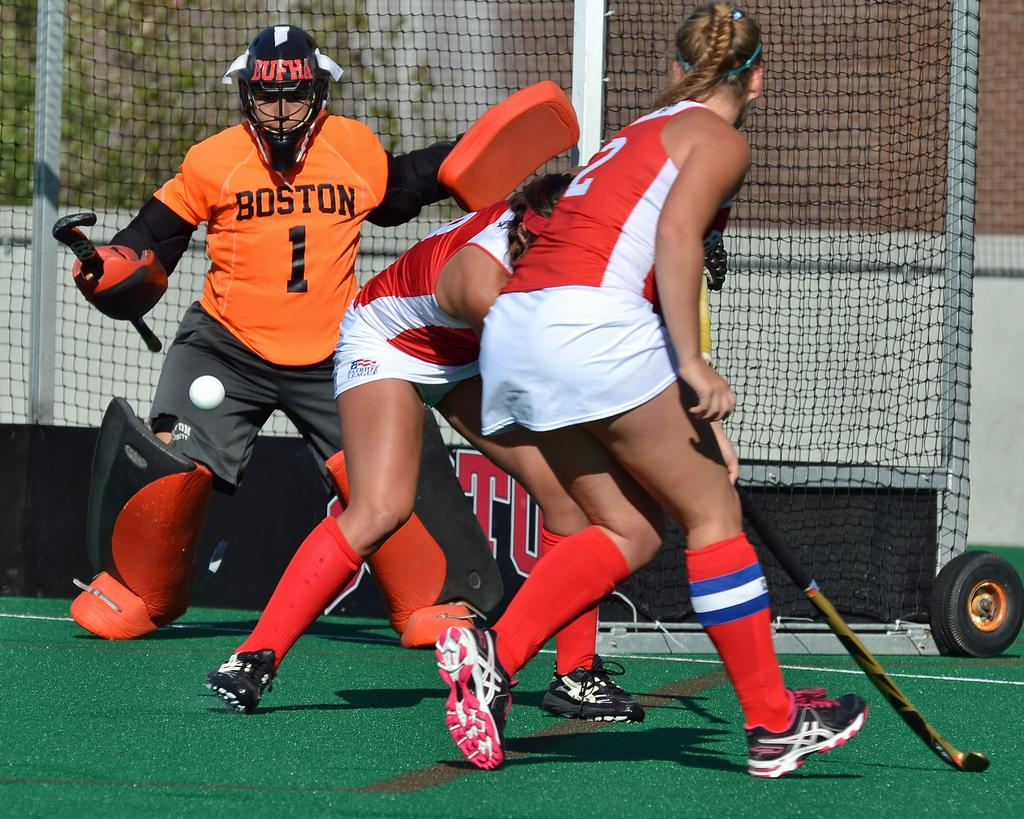Who is playing in the image? There are women in the image. What sport are the women playing? The women are playing hockey. What equipment are the women using to play hockey? The women are holding hockey sticks. Where is the hockey game taking place? The game is taking place on a field. What grade is the hockey team in the image? There is no indication of a hockey team or grade in the image; it simply shows women playing hockey. What type of sweater is the coach wearing in the image? There is no coach or sweater present in the image. 